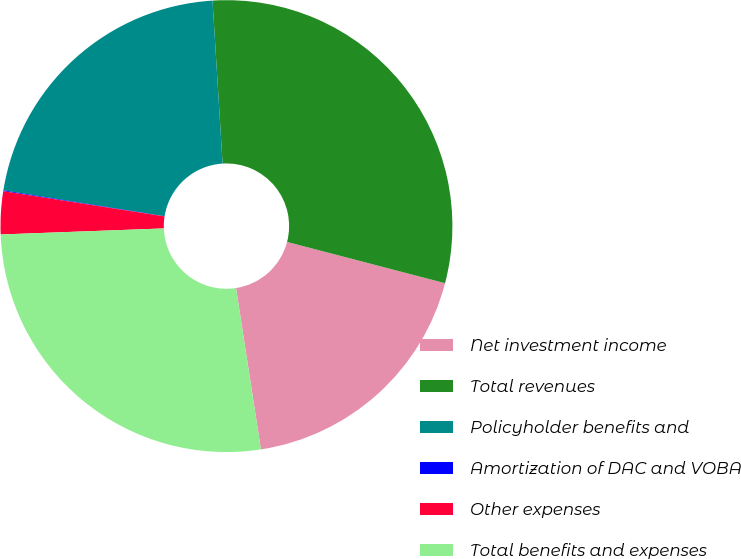Convert chart. <chart><loc_0><loc_0><loc_500><loc_500><pie_chart><fcel>Net investment income<fcel>Total revenues<fcel>Policyholder benefits and<fcel>Amortization of DAC and VOBA<fcel>Other expenses<fcel>Total benefits and expenses<nl><fcel>18.5%<fcel>30.05%<fcel>21.49%<fcel>0.06%<fcel>3.06%<fcel>26.85%<nl></chart> 